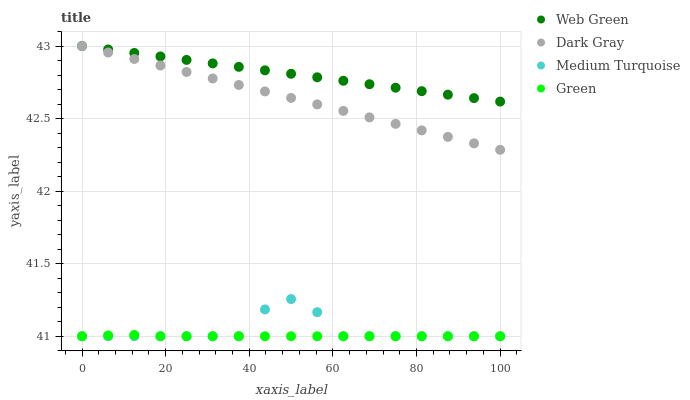Does Green have the minimum area under the curve?
Answer yes or no. Yes. Does Web Green have the maximum area under the curve?
Answer yes or no. Yes. Does Medium Turquoise have the minimum area under the curve?
Answer yes or no. No. Does Medium Turquoise have the maximum area under the curve?
Answer yes or no. No. Is Dark Gray the smoothest?
Answer yes or no. Yes. Is Medium Turquoise the roughest?
Answer yes or no. Yes. Is Green the smoothest?
Answer yes or no. No. Is Green the roughest?
Answer yes or no. No. Does Green have the lowest value?
Answer yes or no. Yes. Does Web Green have the lowest value?
Answer yes or no. No. Does Web Green have the highest value?
Answer yes or no. Yes. Does Medium Turquoise have the highest value?
Answer yes or no. No. Is Medium Turquoise less than Dark Gray?
Answer yes or no. Yes. Is Web Green greater than Green?
Answer yes or no. Yes. Does Medium Turquoise intersect Green?
Answer yes or no. Yes. Is Medium Turquoise less than Green?
Answer yes or no. No. Is Medium Turquoise greater than Green?
Answer yes or no. No. Does Medium Turquoise intersect Dark Gray?
Answer yes or no. No. 